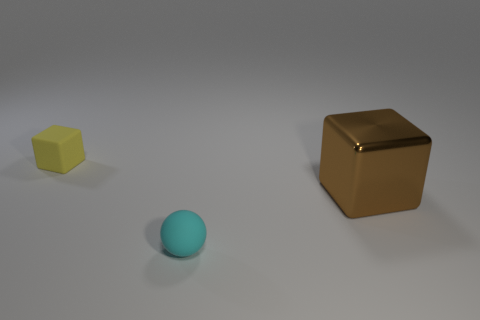What number of cyan things are big metallic objects or tiny objects?
Provide a succinct answer. 1. Is the number of yellow rubber things that are in front of the tiny yellow thing the same as the number of brown objects on the right side of the big brown object?
Make the answer very short. Yes. There is a small thing that is behind the large cube; is its shape the same as the object that is right of the cyan matte object?
Provide a short and direct response. Yes. Is there any other thing that has the same shape as the small cyan matte thing?
Offer a terse response. No. What is the shape of the other small object that is made of the same material as the small yellow thing?
Offer a very short reply. Sphere. Are there the same number of tiny cyan balls behind the big brown shiny cube and yellow rubber objects?
Your answer should be very brief. No. Do the small thing right of the tiny yellow rubber cube and the cube that is to the left of the brown thing have the same material?
Give a very brief answer. Yes. What shape is the tiny rubber object right of the rubber object that is left of the cyan matte object?
Offer a terse response. Sphere. There is a block that is the same material as the cyan ball; what is its color?
Provide a succinct answer. Yellow. Do the matte sphere and the large thing have the same color?
Your answer should be very brief. No. 